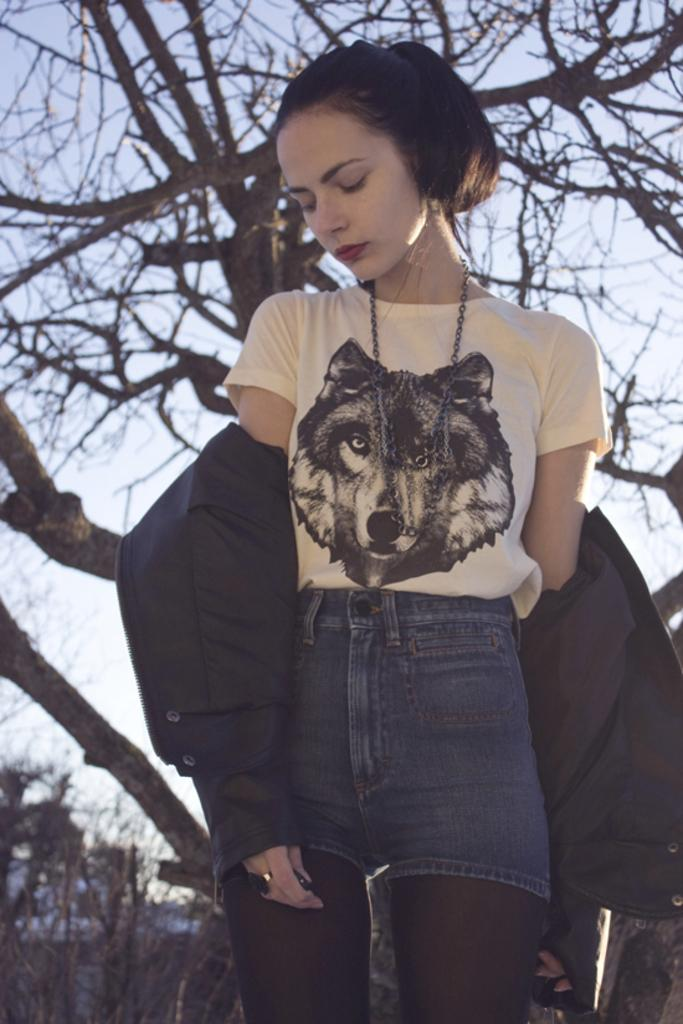Who is the main subject in the image? There is a woman in the image. What is the woman wearing around her neck? The woman is wearing a chain. What type of clothing is the woman wearing on her upper body? The woman is wearing a jacket. What can be seen in the background of the image? Trees and the sky are visible in the background of the image. How would you describe the sky in the image? The sky appears to be cloudy in the image. What type of agreement is the woman signing in the image? There is no agreement visible in the image, and the woman is not signing anything. What is the weight of the trees in the background of the image? The weight of the trees cannot be determined from the image, as they are not physical objects that can be weighed. 